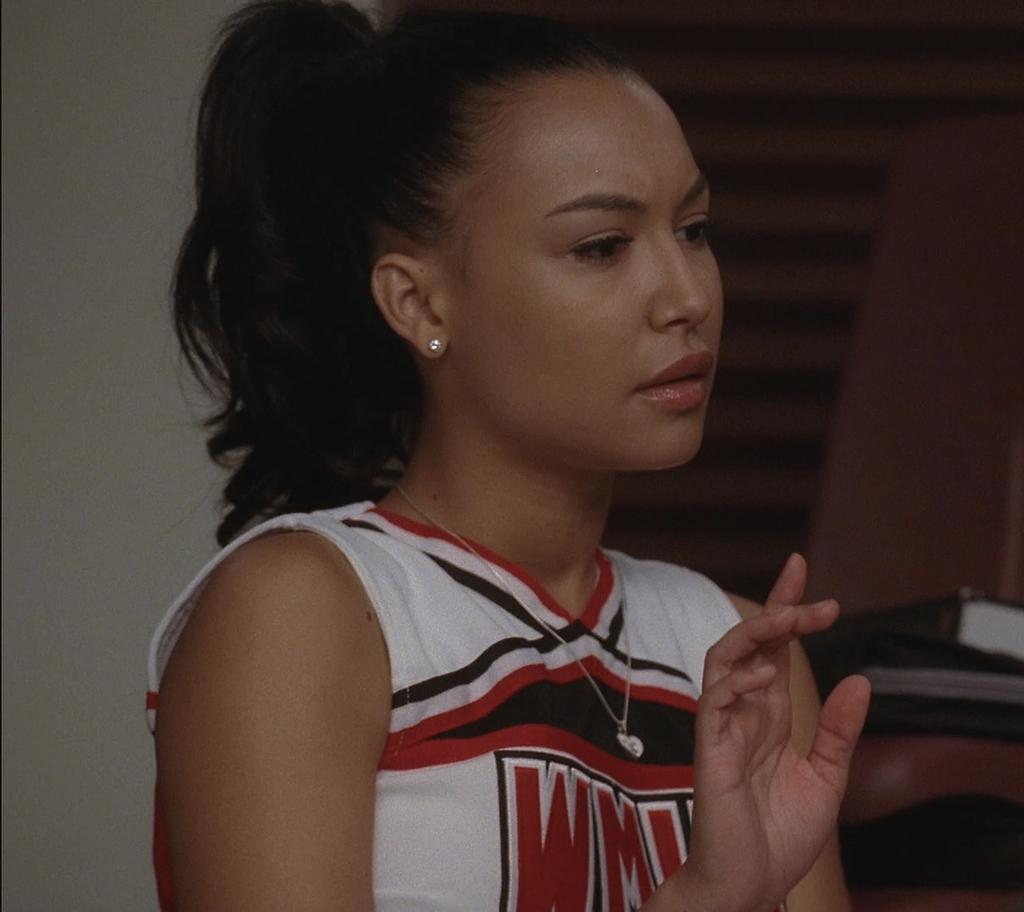Does the girl have an earring?
Your answer should be compact. Yes. 